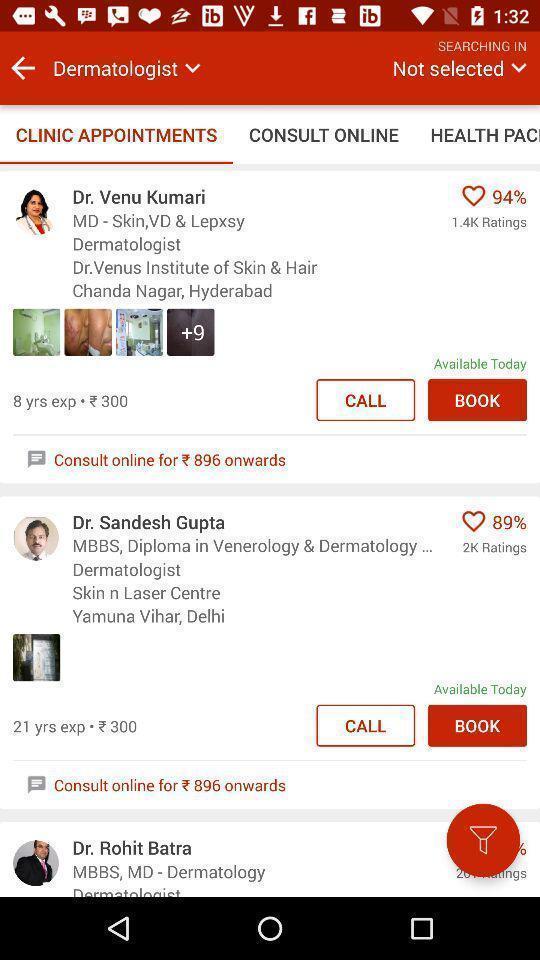Provide a description of this screenshot. Screen showing list of clinic appointments. 